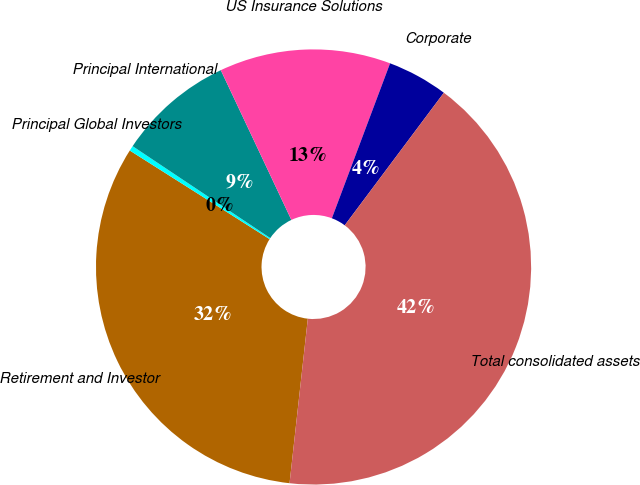<chart> <loc_0><loc_0><loc_500><loc_500><pie_chart><fcel>Retirement and Investor<fcel>Principal Global Investors<fcel>Principal International<fcel>US Insurance Solutions<fcel>Corporate<fcel>Total consolidated assets<nl><fcel>32.23%<fcel>0.38%<fcel>8.62%<fcel>12.73%<fcel>4.5%<fcel>41.54%<nl></chart> 